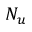Convert formula to latex. <formula><loc_0><loc_0><loc_500><loc_500>N _ { u }</formula> 